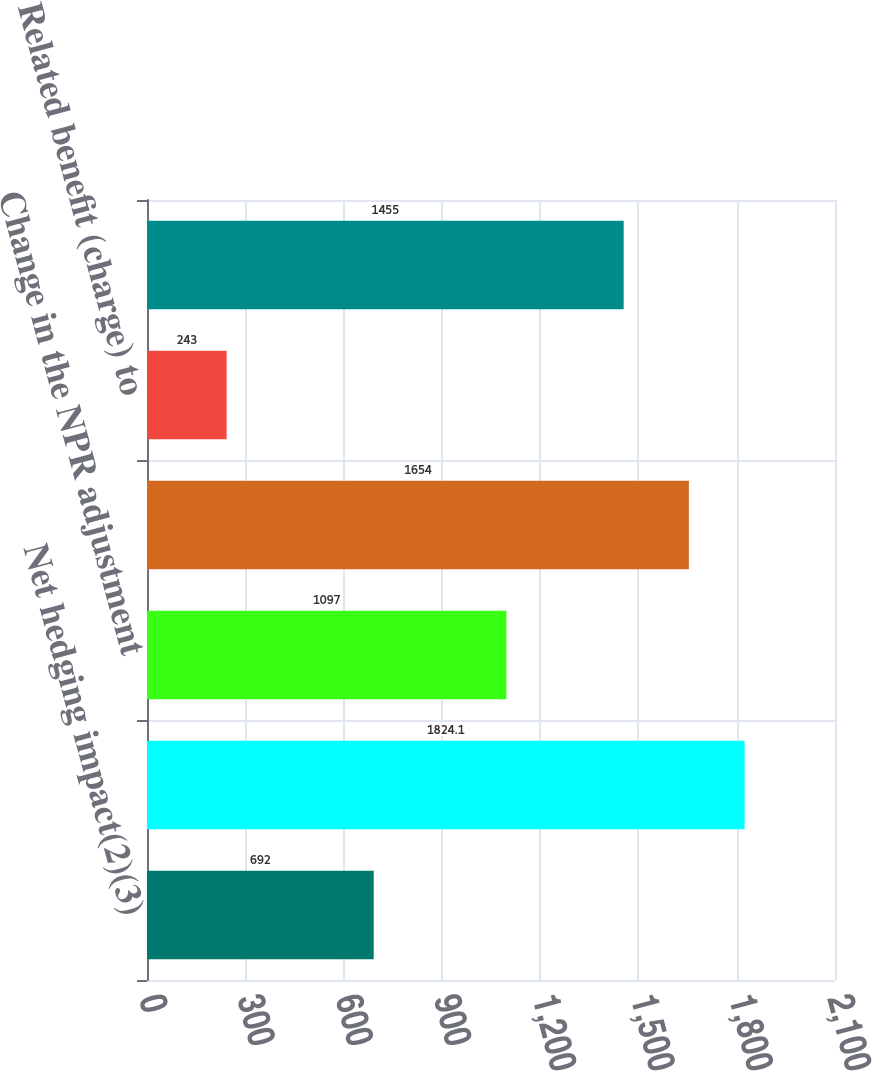Convert chart. <chart><loc_0><loc_0><loc_500><loc_500><bar_chart><fcel>Net hedging impact(2)(3)<fcel>Change in portions of US GAAP<fcel>Change in the NPR adjustment<fcel>Net impact from changes in the<fcel>Related benefit (charge) to<fcel>Net impact of assumption<nl><fcel>692<fcel>1824.1<fcel>1097<fcel>1654<fcel>243<fcel>1455<nl></chart> 